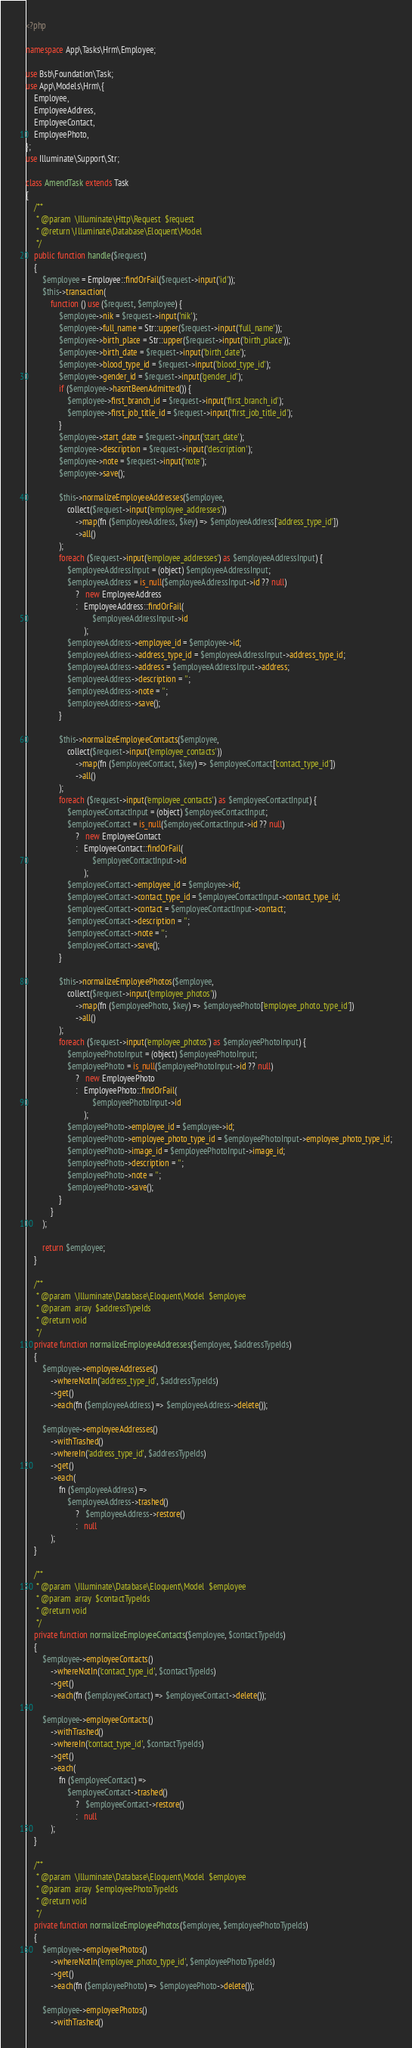<code> <loc_0><loc_0><loc_500><loc_500><_PHP_><?php

namespace App\Tasks\Hrm\Employee;

use Bsb\Foundation\Task;
use App\Models\Hrm\{
    Employee,
    EmployeeAddress,
    EmployeeContact,
    EmployeePhoto,
};
use Illuminate\Support\Str;

class AmendTask extends Task
{
    /**
     * @param  \Illuminate\Http\Request  $request
     * @return \Illuminate\Database\Eloquent\Model
     */
    public function handle($request)
    {
        $employee = Employee::findOrFail($request->input('id'));
        $this->transaction(
            function () use ($request, $employee) {
                $employee->nik = $request->input('nik');
                $employee->full_name = Str::upper($request->input('full_name'));
                $employee->birth_place = Str::upper($request->input('birth_place'));
                $employee->birth_date = $request->input('birth_date');
                $employee->blood_type_id = $request->input('blood_type_id');
                $employee->gender_id = $request->input('gender_id');
                if ($employee->hasntBeenAdmitted()) {
                    $employee->first_branch_id = $request->input('first_branch_id');
                    $employee->first_job_title_id = $request->input('first_job_title_id');
                }
                $employee->start_date = $request->input('start_date');
                $employee->description = $request->input('description');
                $employee->note = $request->input('note');
                $employee->save();

                $this->normalizeEmployeeAddresses($employee,
                    collect($request->input('employee_addresses'))
                        ->map(fn ($employeeAddress, $key) => $employeeAddress['address_type_id'])
                        ->all()
                );
                foreach ($request->input('employee_addresses') as $employeeAddressInput) {
                    $employeeAddressInput = (object) $employeeAddressInput;
                    $employeeAddress = is_null($employeeAddressInput->id ?? null)
                        ?   new EmployeeAddress
                        :   EmployeeAddress::findOrFail(
                                $employeeAddressInput->id
                            );
                    $employeeAddress->employee_id = $employee->id;
                    $employeeAddress->address_type_id = $employeeAddressInput->address_type_id;
                    $employeeAddress->address = $employeeAddressInput->address;
                    $employeeAddress->description = '';
                    $employeeAddress->note = '';
                    $employeeAddress->save();
                }

                $this->normalizeEmployeeContacts($employee,
                    collect($request->input('employee_contacts'))
                        ->map(fn ($employeeContact, $key) => $employeeContact['contact_type_id'])
                        ->all()
                );
                foreach ($request->input('employee_contacts') as $employeeContactInput) {
                    $employeeContactInput = (object) $employeeContactInput;
                    $employeeContact = is_null($employeeContactInput->id ?? null)
                        ?   new EmployeeContact
                        :   EmployeeContact::findOrFail(
                                $employeeContactInput->id
                            );
                    $employeeContact->employee_id = $employee->id;
                    $employeeContact->contact_type_id = $employeeContactInput->contact_type_id;
                    $employeeContact->contact = $employeeContactInput->contact;
                    $employeeContact->description = '';
                    $employeeContact->note = '';
                    $employeeContact->save();
                }

                $this->normalizeEmployeePhotos($employee,
                    collect($request->input('employee_photos'))
                        ->map(fn ($employeePhoto, $key) => $employeePhoto['employee_photo_type_id'])
                        ->all()
                );
                foreach ($request->input('employee_photos') as $employeePhotoInput) {
                    $employeePhotoInput = (object) $employeePhotoInput;
                    $employeePhoto = is_null($employeePhotoInput->id ?? null)
                        ?   new EmployeePhoto
                        :   EmployeePhoto::findOrFail(
                                $employeePhotoInput->id
                            );
                    $employeePhoto->employee_id = $employee->id;
                    $employeePhoto->employee_photo_type_id = $employeePhotoInput->employee_photo_type_id;
                    $employeePhoto->image_id = $employeePhotoInput->image_id;
                    $employeePhoto->description = '';
                    $employeePhoto->note = '';
                    $employeePhoto->save();
                }
            }
        );

        return $employee;
    }

    /**
     * @param  \Illuminate\Database\Eloquent\Model  $employee
     * @param  array  $addressTypeIds
     * @return void
     */
    private function normalizeEmployeeAddresses($employee, $addressTypeIds)
    {
        $employee->employeeAddresses()
            ->whereNotIn('address_type_id', $addressTypeIds)
            ->get()
            ->each(fn ($employeeAddress) => $employeeAddress->delete());

        $employee->employeeAddresses()
            ->withTrashed()
            ->whereIn('address_type_id', $addressTypeIds)
            ->get()
            ->each(
                fn ($employeeAddress) =>
                    $employeeAddress->trashed()
                        ?   $employeeAddress->restore()
                        :   null
            );
    }

    /**
     * @param  \Illuminate\Database\Eloquent\Model  $employee
     * @param  array  $contactTypeIds
     * @return void
     */
    private function normalizeEmployeeContacts($employee, $contactTypeIds)
    {
        $employee->employeeContacts()
            ->whereNotIn('contact_type_id', $contactTypeIds)
            ->get()
            ->each(fn ($employeeContact) => $employeeContact->delete());

        $employee->employeeContacts()
            ->withTrashed()
            ->whereIn('contact_type_id', $contactTypeIds)
            ->get()
            ->each(
                fn ($employeeContact) =>
                    $employeeContact->trashed()
                        ?   $employeeContact->restore()
                        :   null
            );
    }

    /**
     * @param  \Illuminate\Database\Eloquent\Model  $employee
     * @param  array  $employeePhotoTypeIds
     * @return void
     */
    private function normalizeEmployeePhotos($employee, $employeePhotoTypeIds)
    {
        $employee->employeePhotos()
            ->whereNotIn('employee_photo_type_id', $employeePhotoTypeIds)
            ->get()
            ->each(fn ($employeePhoto) => $employeePhoto->delete());

        $employee->employeePhotos()
            ->withTrashed()</code> 